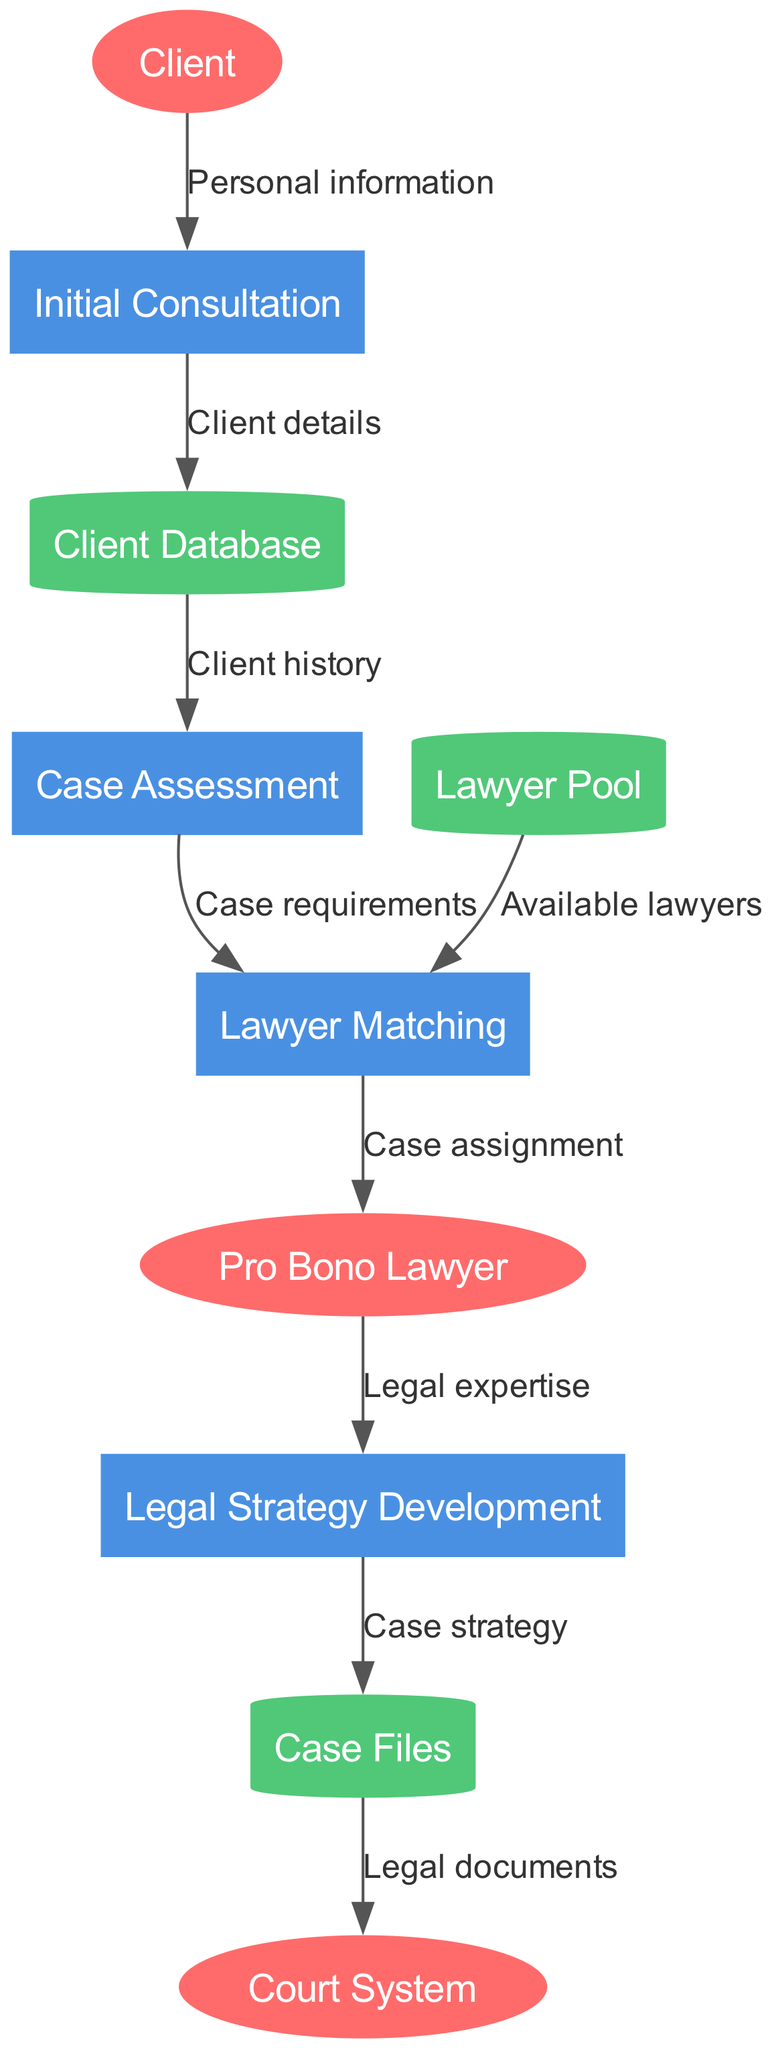What is the first process that the client goes through? The diagram shows that the client first interacts with the "Initial Consultation" process, as indicated by the data flow from the "Client" to "Initial Consultation".
Answer: Initial Consultation How many external entities are represented in the diagram? The diagram lists three external entities: "Client", "Pro Bono Lawyer", and "Court System". Therefore, the total count is three.
Answer: 3 What type of data store is used to maintain the client's information? The "Client Database" is listed as a cylinder shape in the diagram, which indicates that it is used for storing client information.
Answer: Client Database Which process receives "Legal expertise" from the Pro Bono Lawyer? According to the data flow, the "Legal Strategy Development" process receives "Legal expertise" from the "Pro Bono Lawyer".
Answer: Legal Strategy Development What flows from the Case Files to the Court System? The diagram specifies that "Legal documents" flow from "Case Files" to the "Court System".
Answer: Legal documents How many processes are involved in the legal aid clinic’s information flow? The diagram enumerates four processes: "Initial Consultation", "Case Assessment", "Lawyer Matching", and "Legal Strategy Development". Thus, there are four processes in total.
Answer: 4 What type of information is transferred from the "Initial Consultation" to the "Client Database"? The data flow indicates that "Client details" are transferred from the "Initial Consultation" to the "Client Database".
Answer: Client details In which process are "Available lawyers" utilized? The "Lawyer Matching" process uses "Available lawyers" as indicated by the data flow from "Lawyer Pool" to "Lawyer Matching".
Answer: Lawyer Matching What is the relationship between "Case Assessment" and "Lawyer Matching"? The "Case Assessment" process sends "Case requirements" to the "Lawyer Matching" process, establishing a flow of information between these two processes.
Answer: Case requirements 